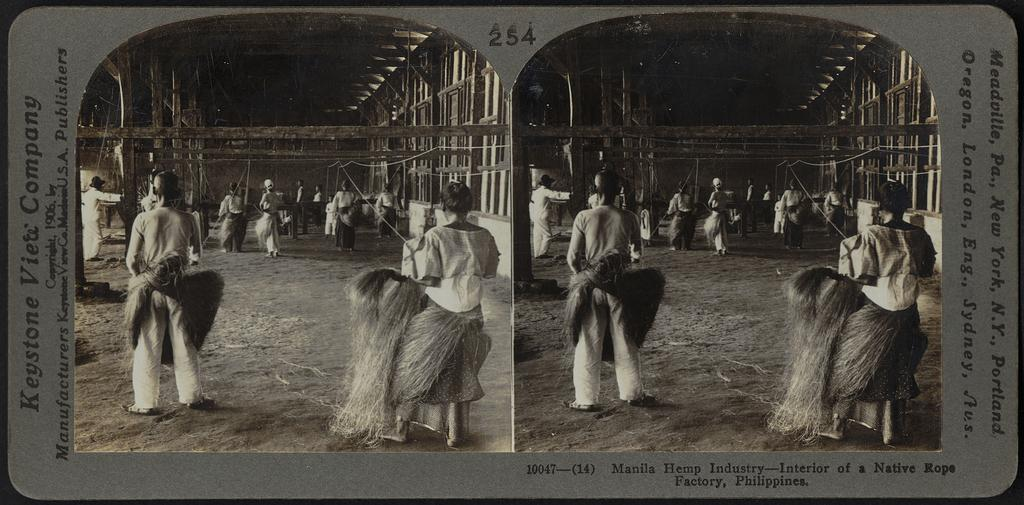What type of content is present in the image? There are similar pictures and text in the image. Can you describe the people visible in the image? There are people visible in the image. How many items can be identified in the image? There are a few things in the image. What material are some of the objects made of in the image? There are wooden objects in the image. What decisions is the committee making in the image? There is no committee present in the image, so no decisions are being made. What type of needle is being used by the team in the image? There is no needle or team present in the image. 